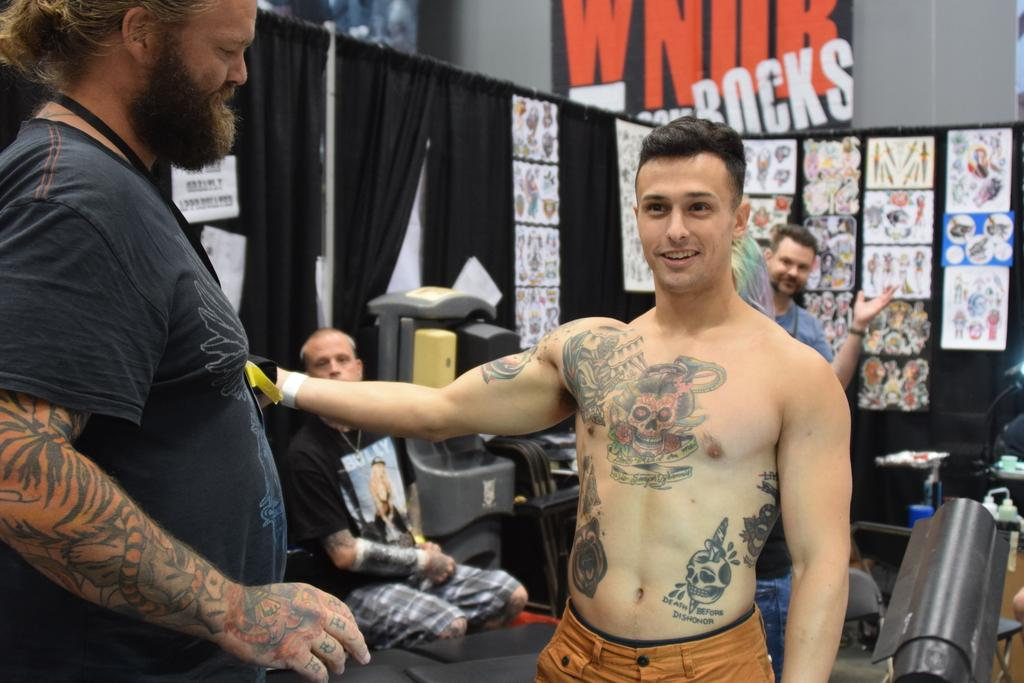What are the men in the image doing? Some men are standing, while others are sitting on chairs in the image. Can you describe the background of the image? There are papers pasted on the curtains, machines, and walls in the background. What type of milk is being served in the image? There is no milk present in the image. What is the iron used for in the image? There is no iron present in the image. 